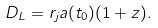Convert formula to latex. <formula><loc_0><loc_0><loc_500><loc_500>D _ { L } = r _ { j } a ( t _ { 0 } ) ( 1 + z ) .</formula> 